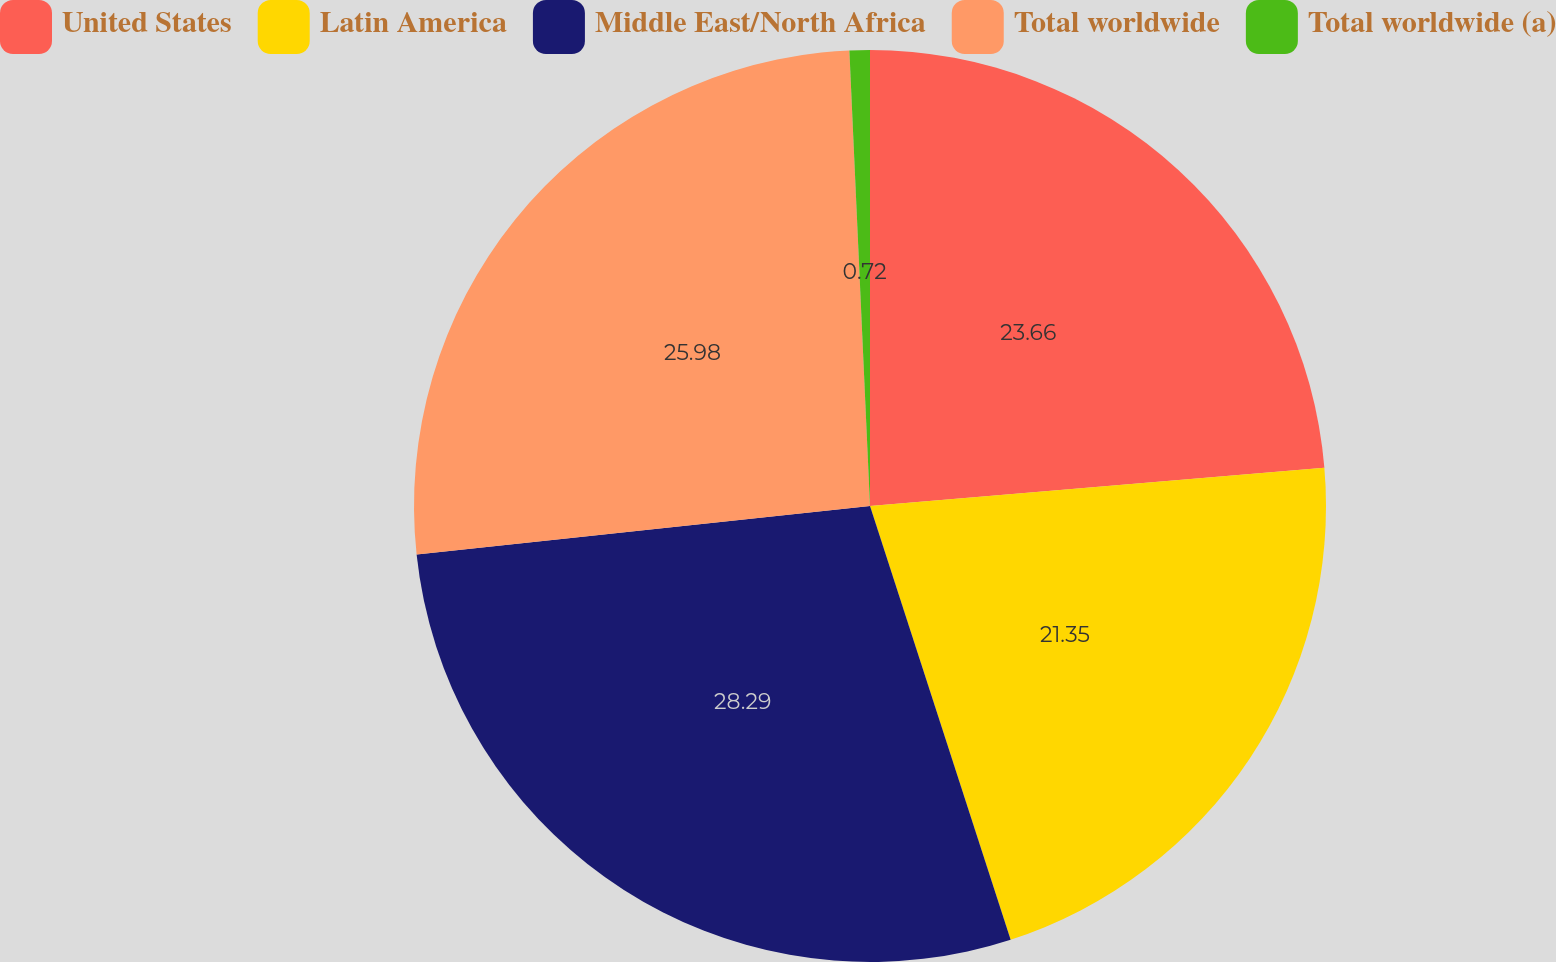Convert chart. <chart><loc_0><loc_0><loc_500><loc_500><pie_chart><fcel>United States<fcel>Latin America<fcel>Middle East/North Africa<fcel>Total worldwide<fcel>Total worldwide (a)<nl><fcel>23.66%<fcel>21.35%<fcel>28.29%<fcel>25.98%<fcel>0.72%<nl></chart> 